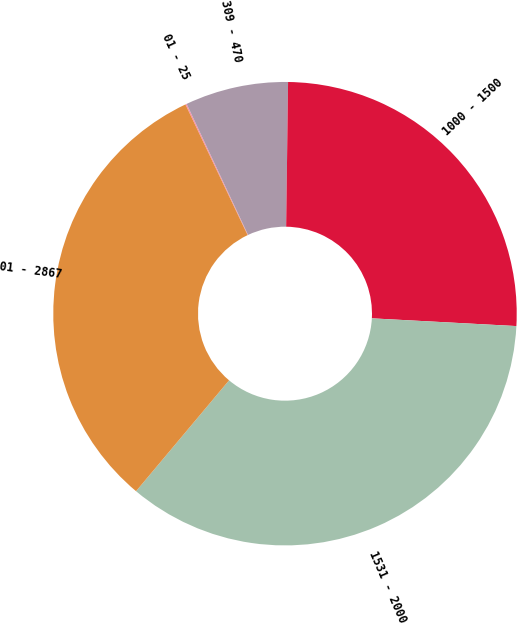Convert chart. <chart><loc_0><loc_0><loc_500><loc_500><pie_chart><fcel>01 - 25<fcel>309 - 470<fcel>1000 - 1500<fcel>1531 - 2000<fcel>01 - 2867<nl><fcel>0.09%<fcel>7.19%<fcel>25.64%<fcel>35.26%<fcel>31.82%<nl></chart> 